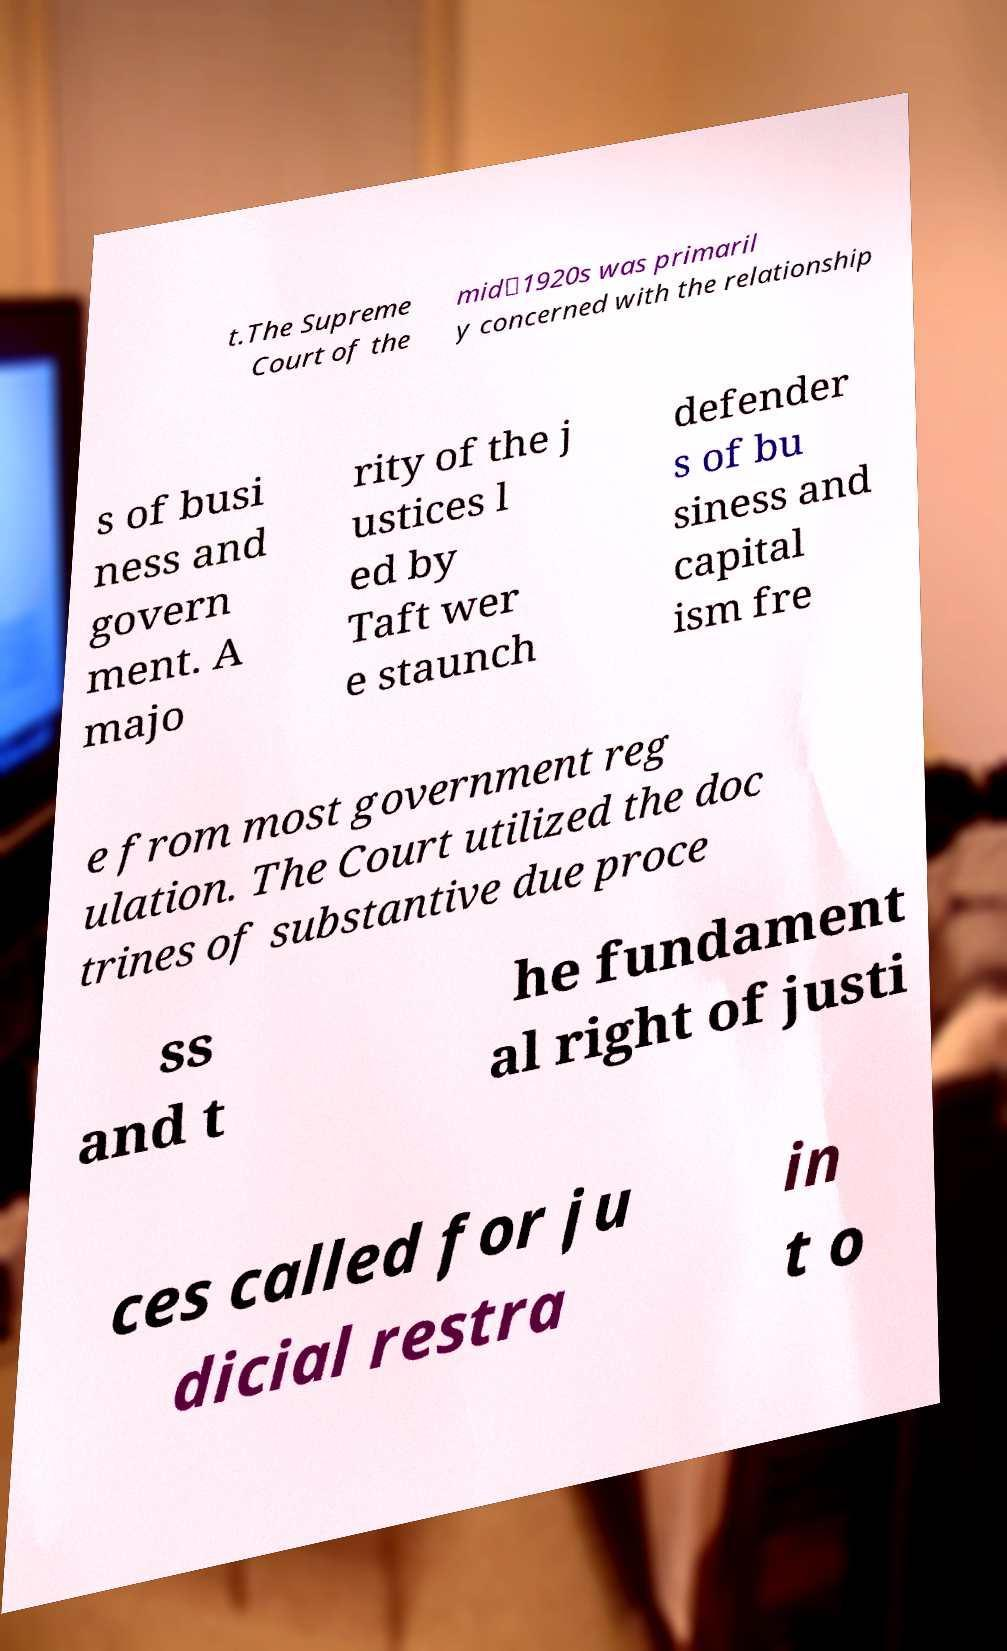What messages or text are displayed in this image? I need them in a readable, typed format. t.The Supreme Court of the mid‑1920s was primaril y concerned with the relationship s of busi ness and govern ment. A majo rity of the j ustices l ed by Taft wer e staunch defender s of bu siness and capital ism fre e from most government reg ulation. The Court utilized the doc trines of substantive due proce ss and t he fundament al right of justi ces called for ju dicial restra in t o 